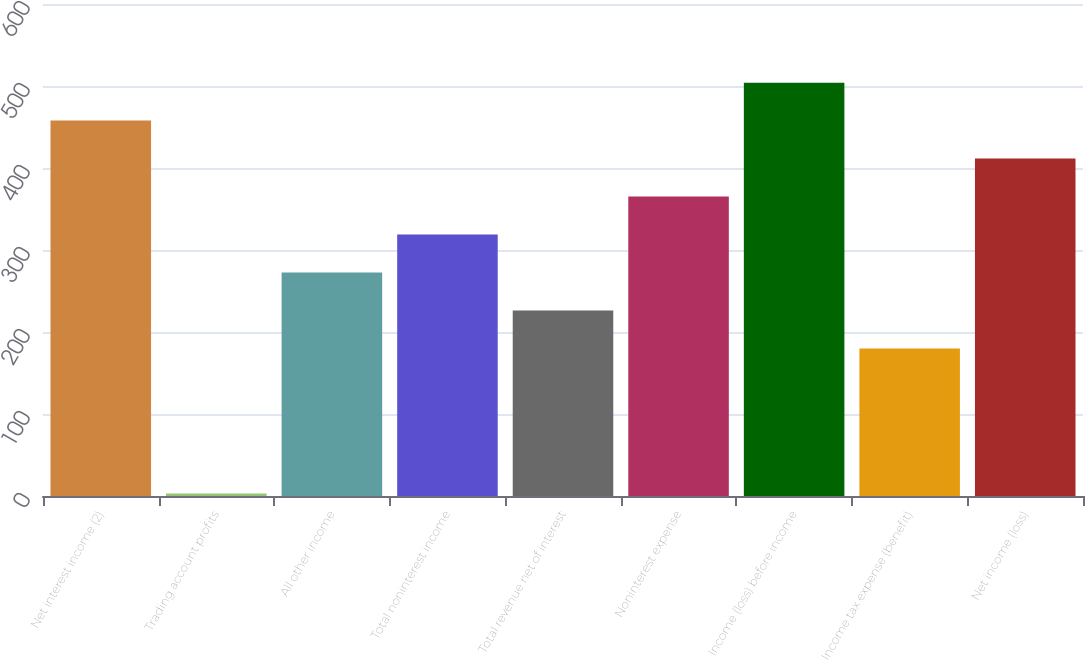Convert chart. <chart><loc_0><loc_0><loc_500><loc_500><bar_chart><fcel>Net interest income (2)<fcel>Trading account profits<fcel>All other income<fcel>Total noninterest income<fcel>Total revenue net of interest<fcel>Noninterest expense<fcel>Income (loss) before income<fcel>Income tax expense (benefit)<fcel>Net income (loss)<nl><fcel>457.8<fcel>3<fcel>272.6<fcel>318.9<fcel>226.3<fcel>365.2<fcel>504.1<fcel>180<fcel>411.5<nl></chart> 